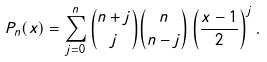Convert formula to latex. <formula><loc_0><loc_0><loc_500><loc_500>P _ { n } ( x ) = \sum _ { j = 0 } ^ { n } \binom { n + j } { j } \binom { n } { n - j } \left ( \frac { x - 1 } { 2 } \right ) ^ { j } .</formula> 